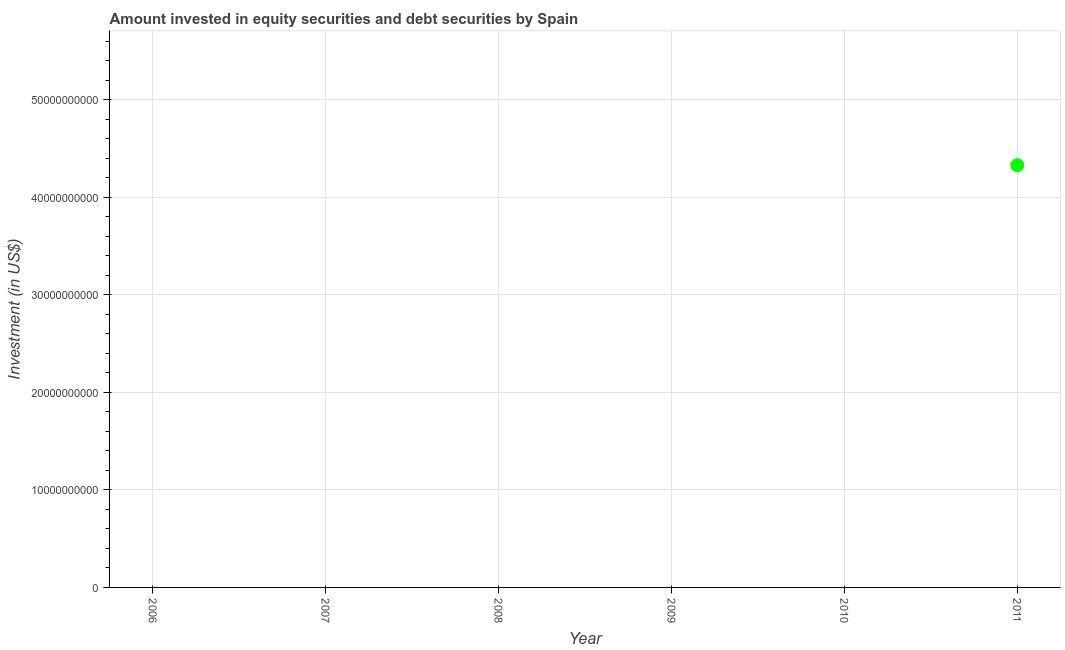What is the portfolio investment in 2011?
Keep it short and to the point. 4.33e+1. Across all years, what is the maximum portfolio investment?
Your answer should be compact. 4.33e+1. Across all years, what is the minimum portfolio investment?
Offer a very short reply. 0. What is the sum of the portfolio investment?
Provide a succinct answer. 4.33e+1. What is the average portfolio investment per year?
Offer a very short reply. 7.22e+09. What is the median portfolio investment?
Keep it short and to the point. 0. What is the difference between the highest and the lowest portfolio investment?
Offer a very short reply. 4.33e+1. How many dotlines are there?
Your answer should be very brief. 1. How many years are there in the graph?
Ensure brevity in your answer.  6. Are the values on the major ticks of Y-axis written in scientific E-notation?
Offer a very short reply. No. What is the title of the graph?
Make the answer very short. Amount invested in equity securities and debt securities by Spain. What is the label or title of the Y-axis?
Provide a short and direct response. Investment (in US$). What is the Investment (in US$) in 2006?
Give a very brief answer. 0. What is the Investment (in US$) in 2009?
Provide a short and direct response. 0. What is the Investment (in US$) in 2011?
Provide a succinct answer. 4.33e+1. 